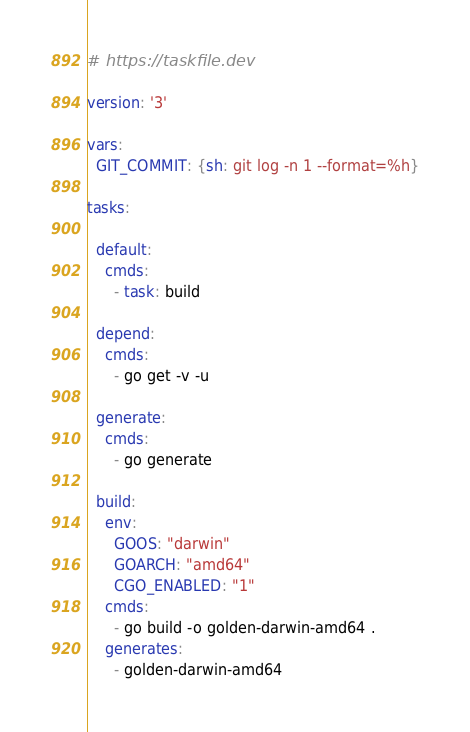<code> <loc_0><loc_0><loc_500><loc_500><_YAML_># https://taskfile.dev

version: '3'

vars:
  GIT_COMMIT: {sh: git log -n 1 --format=%h}

tasks:

  default:
    cmds:
      - task: build

  depend:
    cmds:
      - go get -v -u

  generate:
    cmds:
      - go generate

  build:
    env:
      GOOS: "darwin"
      GOARCH: "amd64"
      CGO_ENABLED: "1"
    cmds:
      - go build -o golden-darwin-amd64 .
    generates:
      - golden-darwin-amd64
</code> 